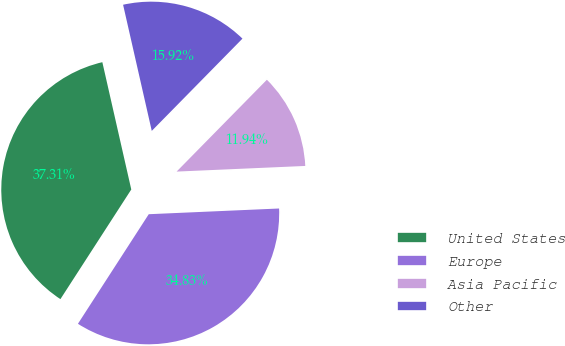Convert chart. <chart><loc_0><loc_0><loc_500><loc_500><pie_chart><fcel>United States<fcel>Europe<fcel>Asia Pacific<fcel>Other<nl><fcel>37.31%<fcel>34.83%<fcel>11.94%<fcel>15.92%<nl></chart> 